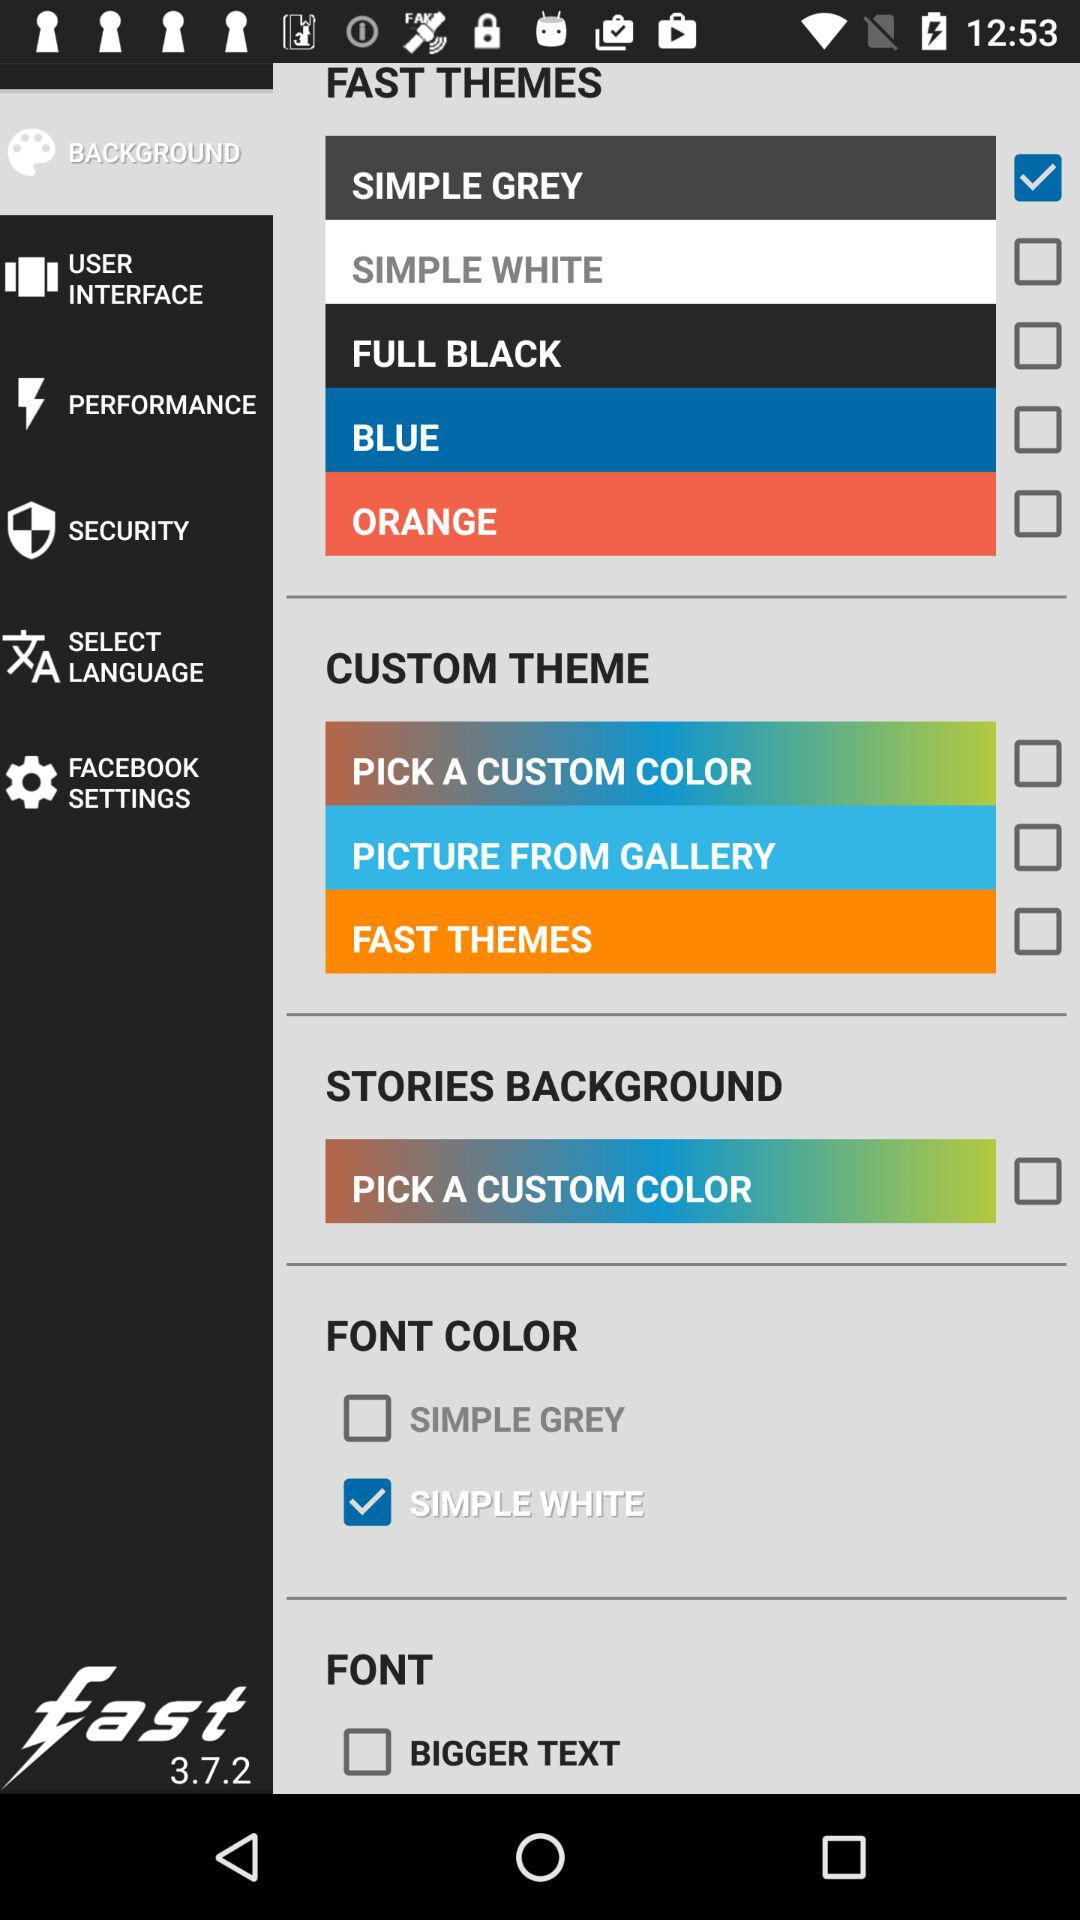Which is the selected "FAST THEMES"? The selected "FAST THEMES" is "SIMPLE GREY". 